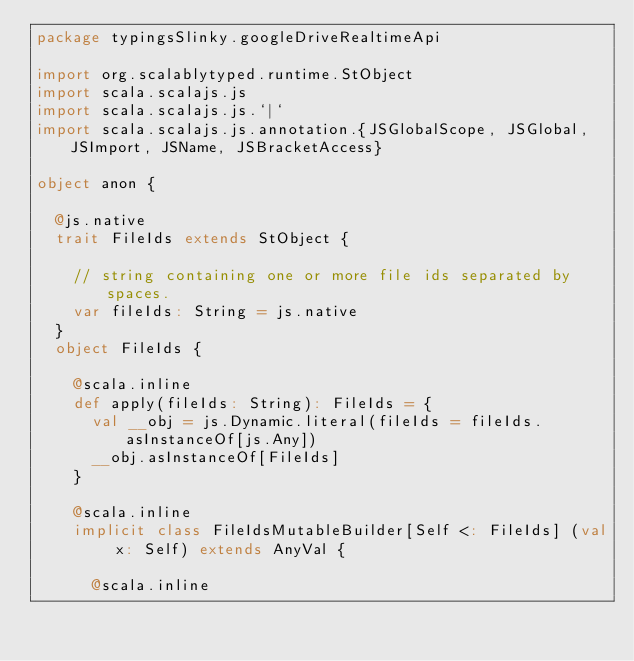<code> <loc_0><loc_0><loc_500><loc_500><_Scala_>package typingsSlinky.googleDriveRealtimeApi

import org.scalablytyped.runtime.StObject
import scala.scalajs.js
import scala.scalajs.js.`|`
import scala.scalajs.js.annotation.{JSGlobalScope, JSGlobal, JSImport, JSName, JSBracketAccess}

object anon {
  
  @js.native
  trait FileIds extends StObject {
    
    // string containing one or more file ids separated by spaces.
    var fileIds: String = js.native
  }
  object FileIds {
    
    @scala.inline
    def apply(fileIds: String): FileIds = {
      val __obj = js.Dynamic.literal(fileIds = fileIds.asInstanceOf[js.Any])
      __obj.asInstanceOf[FileIds]
    }
    
    @scala.inline
    implicit class FileIdsMutableBuilder[Self <: FileIds] (val x: Self) extends AnyVal {
      
      @scala.inline</code> 